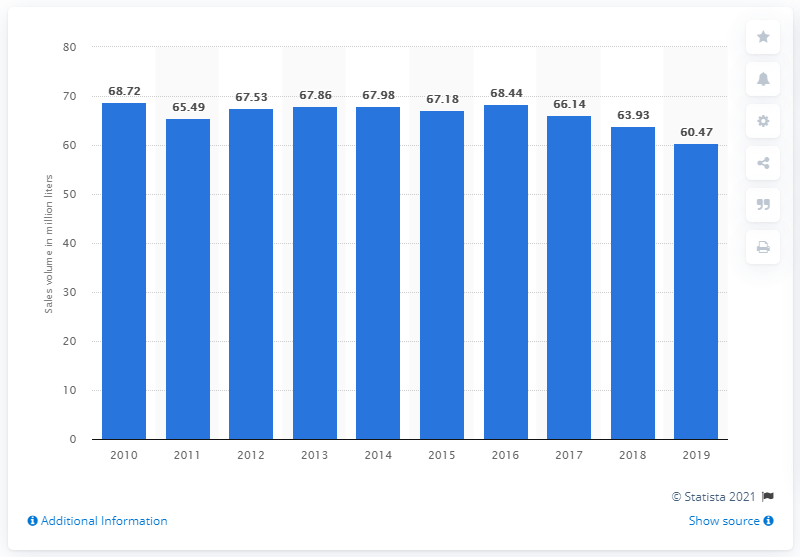Give some essential details in this illustration. The sales volume of beer in Saskatchewan in the 2019 fiscal year was 60.47 million liters. 